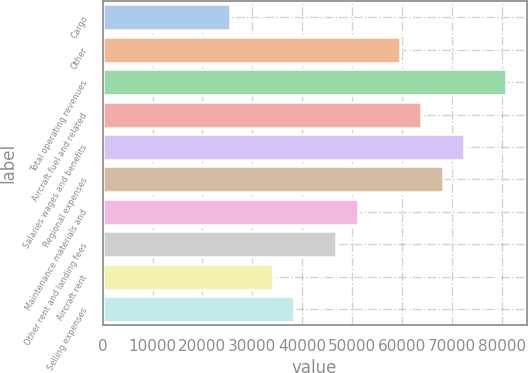Convert chart to OTSL. <chart><loc_0><loc_0><loc_500><loc_500><bar_chart><fcel>Cargo<fcel>Other<fcel>Total operating revenues<fcel>Aircraft fuel and related<fcel>Salaries wages and benefits<fcel>Regional expenses<fcel>Maintenance materials and<fcel>Other rent and landing fees<fcel>Aircraft rent<fcel>Selling expenses<nl><fcel>25574.2<fcel>59669.8<fcel>80979.5<fcel>63931.7<fcel>72455.6<fcel>68193.6<fcel>51145.9<fcel>46883.9<fcel>34098.1<fcel>38360.1<nl></chart> 